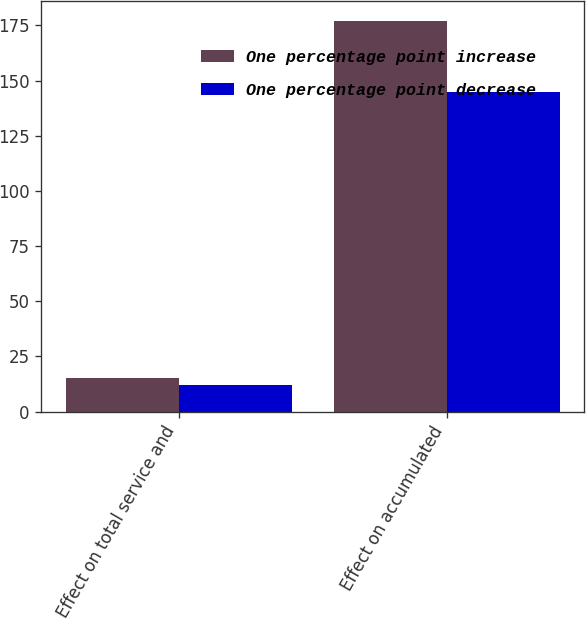Convert chart to OTSL. <chart><loc_0><loc_0><loc_500><loc_500><stacked_bar_chart><ecel><fcel>Effect on total service and<fcel>Effect on accumulated<nl><fcel>One percentage point increase<fcel>15<fcel>177<nl><fcel>One percentage point decrease<fcel>12<fcel>145<nl></chart> 